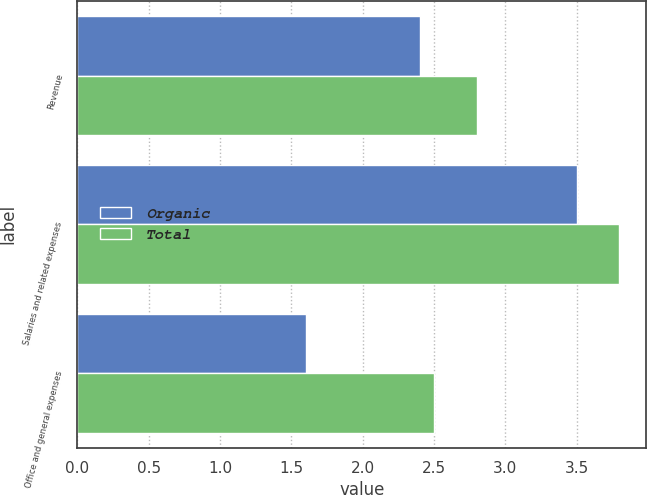<chart> <loc_0><loc_0><loc_500><loc_500><stacked_bar_chart><ecel><fcel>Revenue<fcel>Salaries and related expenses<fcel>Office and general expenses<nl><fcel>Organic<fcel>2.4<fcel>3.5<fcel>1.6<nl><fcel>Total<fcel>2.8<fcel>3.8<fcel>2.5<nl></chart> 